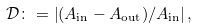<formula> <loc_0><loc_0><loc_500><loc_500>\mathcal { D } \colon = \left | ( A _ { \text {in} } - A _ { \text {out} } ) / A _ { \text {in} } \right | ,</formula> 